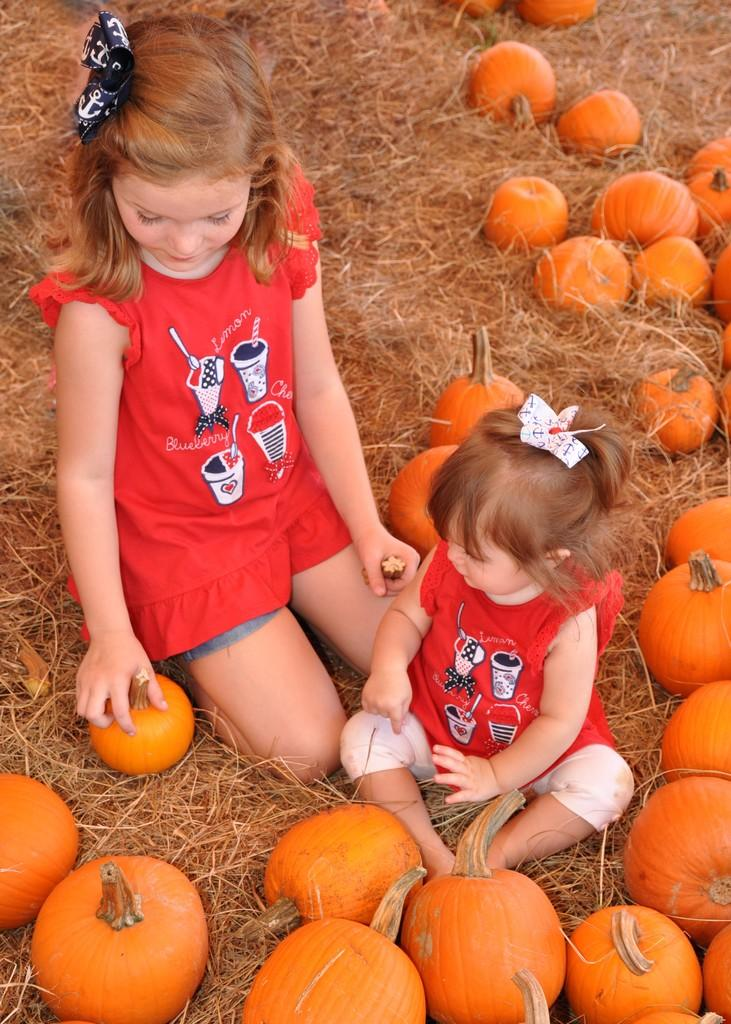How many children are in the image? There are two little girls in the image. What are the girls sitting on? The girls are sitting on dry grass. What are the girls doing in the image? The girls are playing with pumpkins. What type of apparel is the girls wearing for swimming in the image? There is no indication that the girls are swimming or wearing swim apparel in the image. 